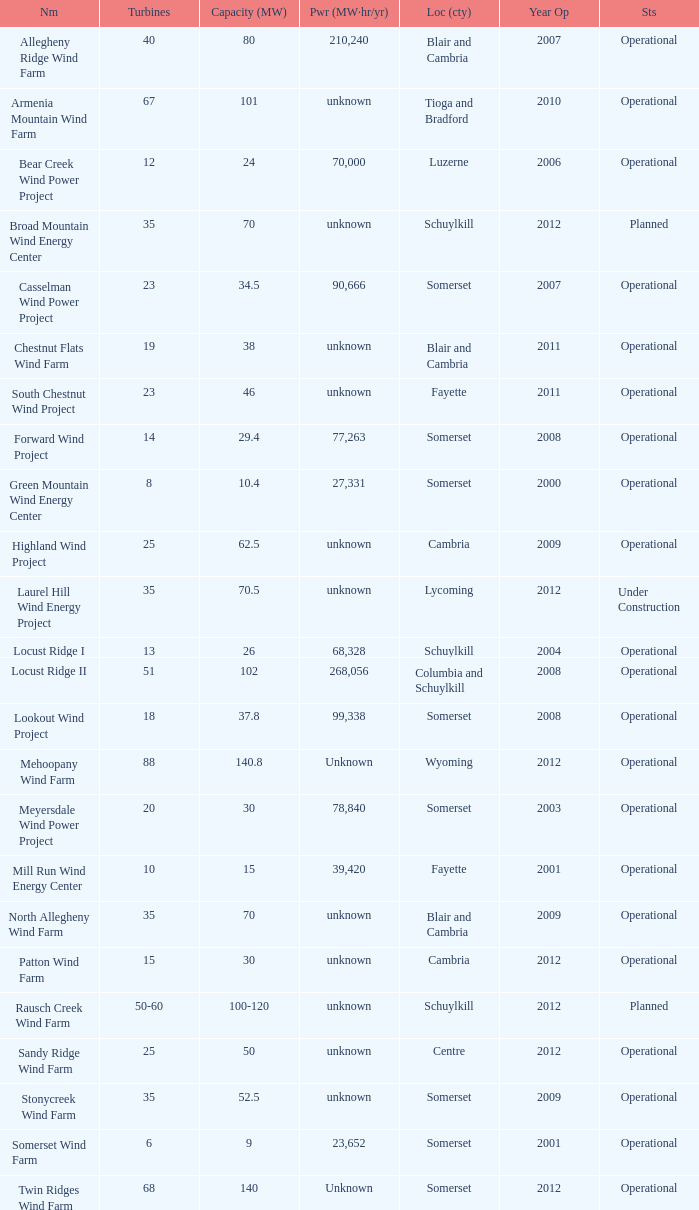What farm has a capacity of 70 and is operational? North Allegheny Wind Farm. 